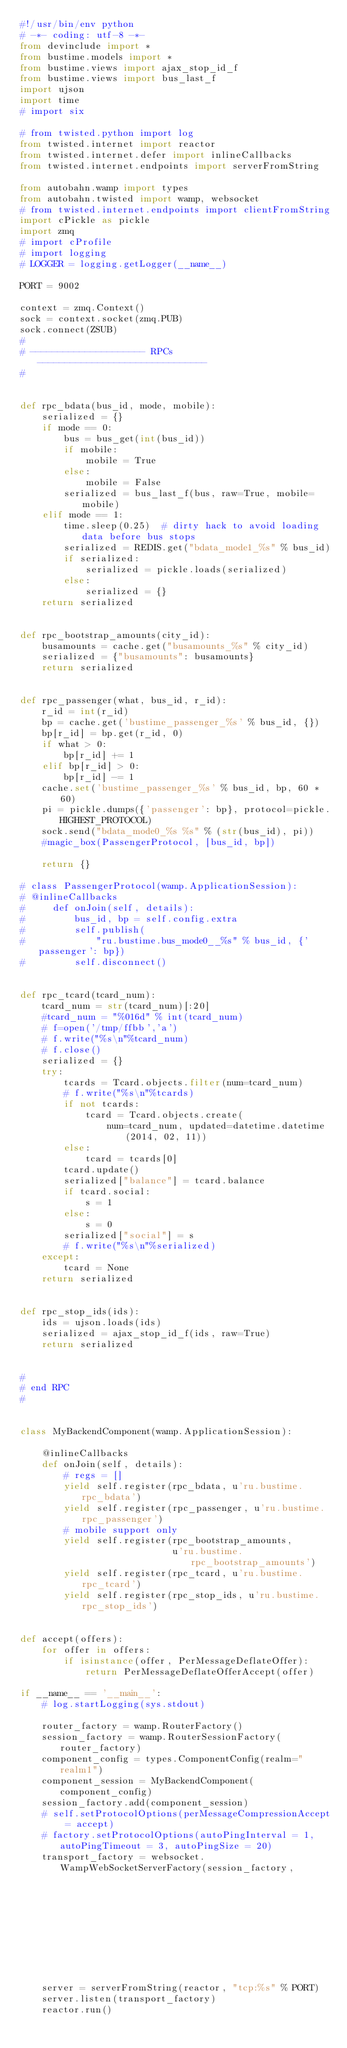<code> <loc_0><loc_0><loc_500><loc_500><_Python_>#!/usr/bin/env python
# -*- coding: utf-8 -*-
from devinclude import *
from bustime.models import *
from bustime.views import ajax_stop_id_f
from bustime.views import bus_last_f
import ujson
import time
# import six

# from twisted.python import log
from twisted.internet import reactor
from twisted.internet.defer import inlineCallbacks
from twisted.internet.endpoints import serverFromString

from autobahn.wamp import types
from autobahn.twisted import wamp, websocket
# from twisted.internet.endpoints import clientFromString
import cPickle as pickle
import zmq
# import cProfile
# import logging
# LOGGER = logging.getLogger(__name__)

PORT = 9002

context = zmq.Context()
sock = context.socket(zmq.PUB)
sock.connect(ZSUB)
#
# --------------------- RPCs -------------------------------
#


def rpc_bdata(bus_id, mode, mobile):
    serialized = {}
    if mode == 0:
        bus = bus_get(int(bus_id))
        if mobile:
            mobile = True
        else:
            mobile = False
        serialized = bus_last_f(bus, raw=True, mobile=mobile)
    elif mode == 1:
        time.sleep(0.25)  # dirty hack to avoid loading data before bus stops
        serialized = REDIS.get("bdata_mode1_%s" % bus_id)
        if serialized:
            serialized = pickle.loads(serialized)
        else:
            serialized = {}
    return serialized


def rpc_bootstrap_amounts(city_id):
    busamounts = cache.get("busamounts_%s" % city_id)
    serialized = {"busamounts": busamounts}
    return serialized


def rpc_passenger(what, bus_id, r_id):
    r_id = int(r_id)
    bp = cache.get('bustime_passenger_%s' % bus_id, {})
    bp[r_id] = bp.get(r_id, 0)
    if what > 0:
        bp[r_id] += 1
    elif bp[r_id] > 0:
        bp[r_id] -= 1
    cache.set('bustime_passenger_%s' % bus_id, bp, 60 * 60)
    pi = pickle.dumps({'passenger': bp}, protocol=pickle.HIGHEST_PROTOCOL)
    sock.send("bdata_mode0_%s %s" % (str(bus_id), pi))
    #magic_box(PassengerProtocol, [bus_id, bp])

    return {}

# class PassengerProtocol(wamp.ApplicationSession):
# @inlineCallbacks
#     def onJoin(self, details):
#         bus_id, bp = self.config.extra
#         self.publish(
#             "ru.bustime.bus_mode0__%s" % bus_id, {'passenger': bp})
#         self.disconnect()


def rpc_tcard(tcard_num):
    tcard_num = str(tcard_num)[:20]
    #tcard_num = "%016d" % int(tcard_num)
    # f=open('/tmp/ffbb','a')
    # f.write("%s\n"%tcard_num)
    # f.close()
    serialized = {}
    try:
        tcards = Tcard.objects.filter(num=tcard_num)
        # f.write("%s\n"%tcards)
        if not tcards:
            tcard = Tcard.objects.create(
                num=tcard_num, updated=datetime.datetime(2014, 02, 11))
        else:
            tcard = tcards[0]
        tcard.update()
        serialized["balance"] = tcard.balance
        if tcard.social:
            s = 1
        else:
            s = 0
        serialized["social"] = s
        # f.write("%s\n"%serialized)
    except:
        tcard = None
    return serialized


def rpc_stop_ids(ids):
    ids = ujson.loads(ids)
    serialized = ajax_stop_id_f(ids, raw=True)
    return serialized


#
# end RPC
#


class MyBackendComponent(wamp.ApplicationSession):

    @inlineCallbacks
    def onJoin(self, details):
        # regs = []
        yield self.register(rpc_bdata, u'ru.bustime.rpc_bdata')
        yield self.register(rpc_passenger, u'ru.bustime.rpc_passenger')
        # mobile support only
        yield self.register(rpc_bootstrap_amounts,
                            u'ru.bustime.rpc_bootstrap_amounts')
        yield self.register(rpc_tcard, u'ru.bustime.rpc_tcard')
        yield self.register(rpc_stop_ids, u'ru.bustime.rpc_stop_ids')


def accept(offers):
    for offer in offers:
        if isinstance(offer, PerMessageDeflateOffer):
            return PerMessageDeflateOfferAccept(offer)

if __name__ == '__main__':
    # log.startLogging(sys.stdout)

    router_factory = wamp.RouterFactory()
    session_factory = wamp.RouterSessionFactory(router_factory)
    component_config = types.ComponentConfig(realm="realm1")
    component_session = MyBackendComponent(component_config)
    session_factory.add(component_session)
    # self.setProtocolOptions(perMessageCompressionAccept = accept)
    # factory.setProtocolOptions(autoPingInterval = 1, autoPingTimeout = 3, autoPingSize = 20)
    transport_factory = websocket.WampWebSocketServerFactory(session_factory,
                                                             debug=False,
                                                             debug_wamp=False)
    server = serverFromString(reactor, "tcp:%s" % PORT)
    server.listen(transport_factory)
    reactor.run()
</code> 